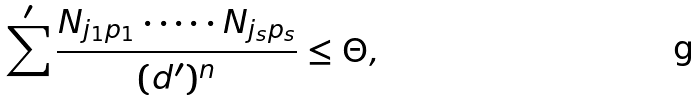<formula> <loc_0><loc_0><loc_500><loc_500>\sum ^ { \prime } \frac { N _ { j _ { 1 } p _ { 1 } } \cdot \dots \cdot N _ { j _ { s } p _ { s } } } { ( d ^ { \prime } ) ^ { n } } \leq \Theta ,</formula> 